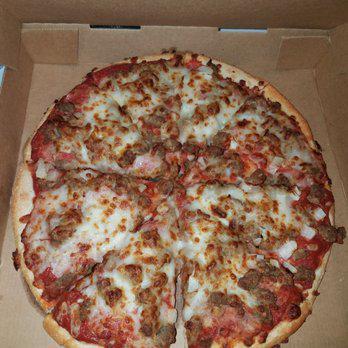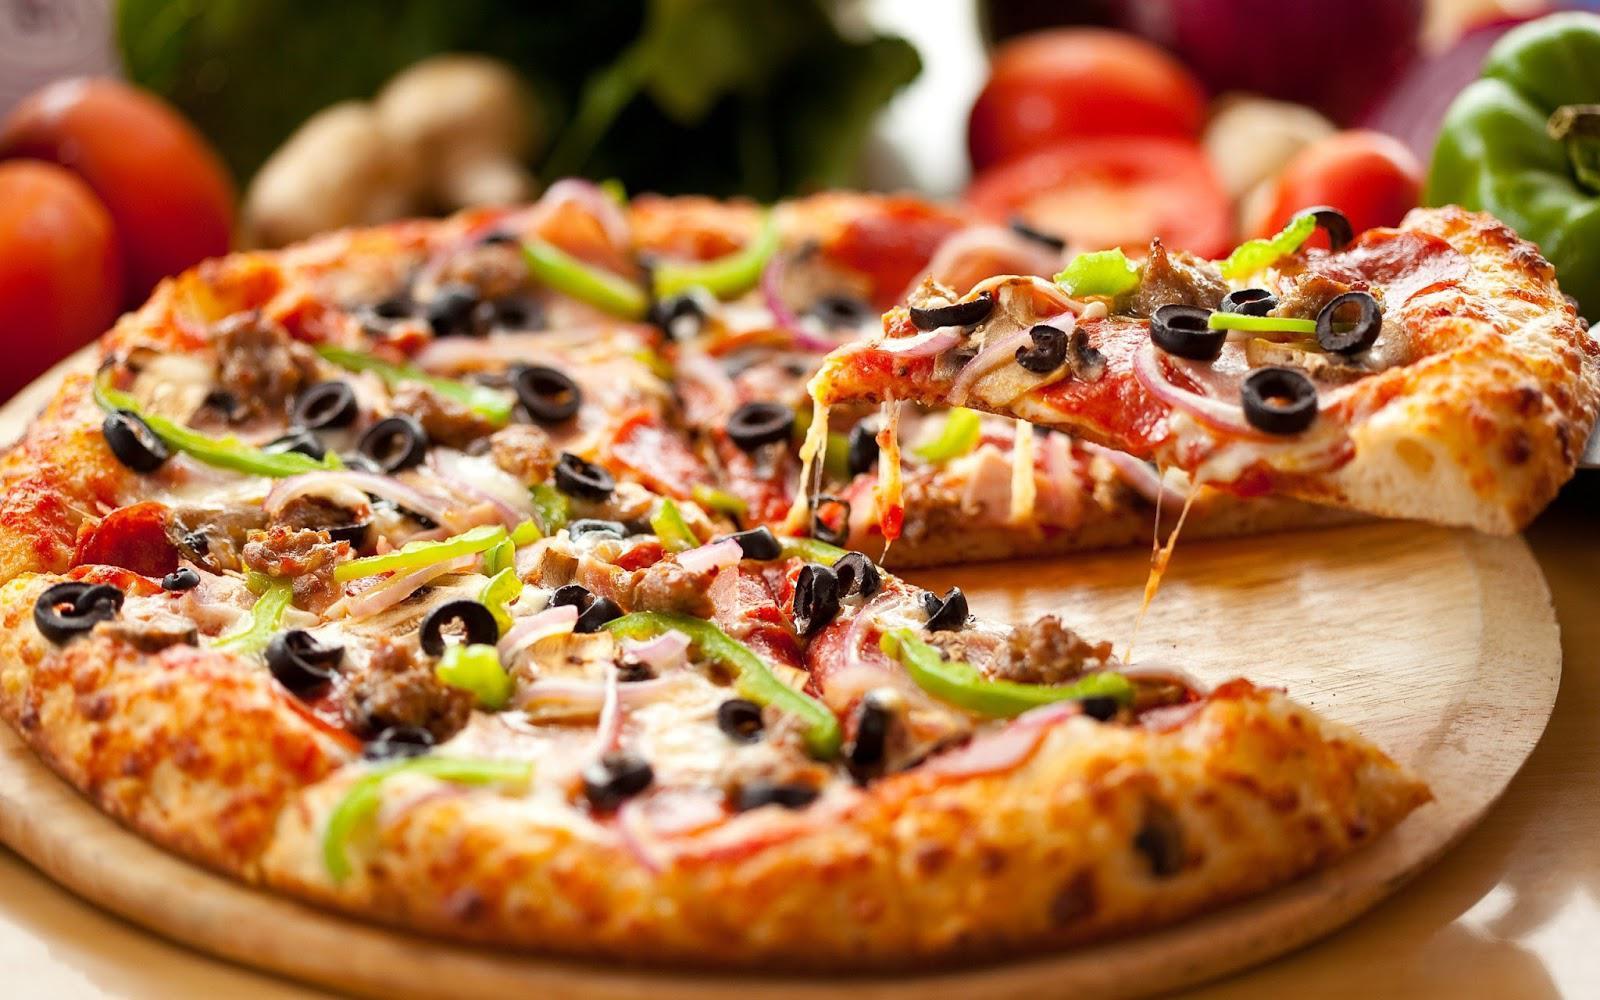The first image is the image on the left, the second image is the image on the right. For the images displayed, is the sentence "At least one of the pizzas has sliced olives on it." factually correct? Answer yes or no. Yes. The first image is the image on the left, the second image is the image on the right. Given the left and right images, does the statement "There are two round full pizzas." hold true? Answer yes or no. No. 